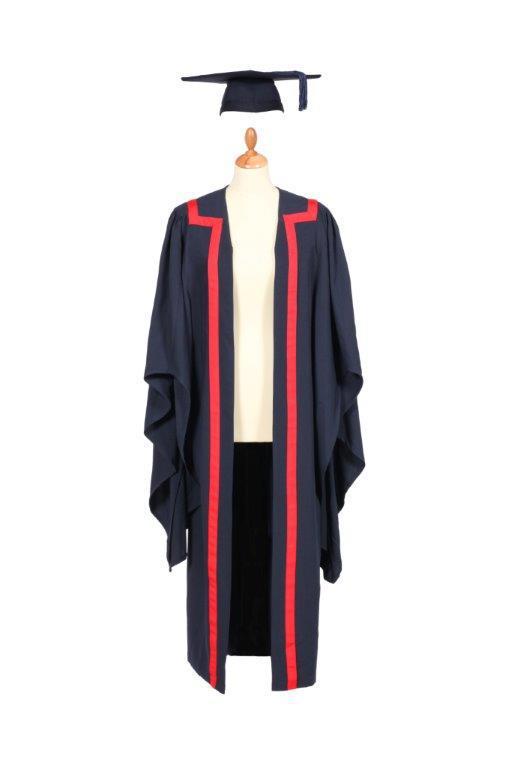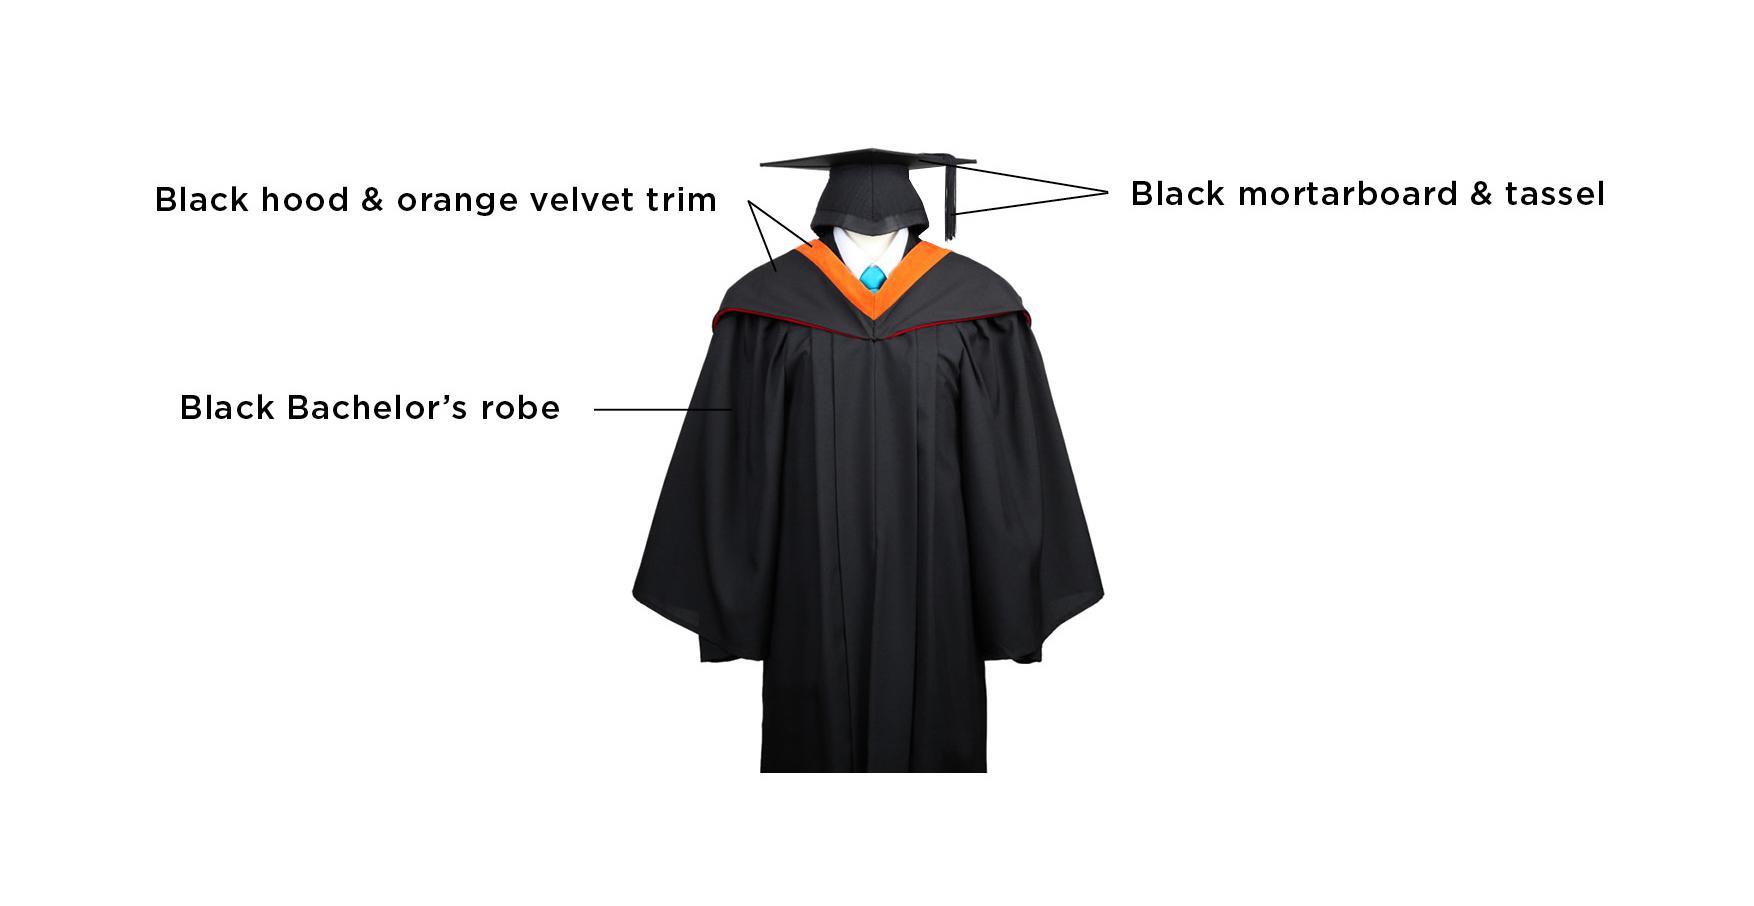The first image is the image on the left, the second image is the image on the right. Assess this claim about the two images: "At least one image shows predominantly black gown modeled by a human.". Correct or not? Answer yes or no. No. The first image is the image on the left, the second image is the image on the right. Assess this claim about the two images: "No graduation attire is modeled by a human, and at least one graduation robe is on a headless mannequin form.". Correct or not? Answer yes or no. Yes. 